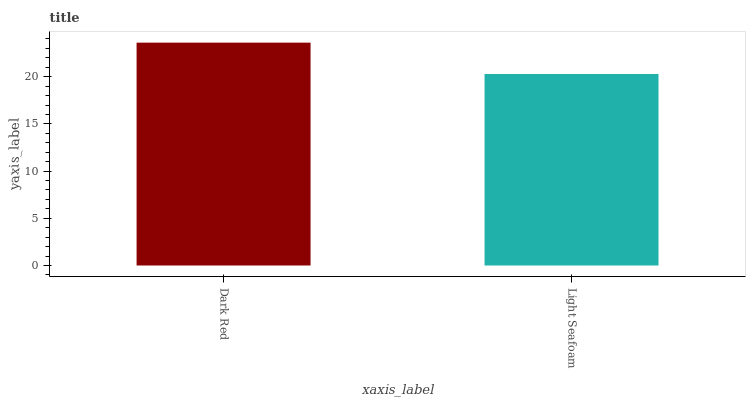Is Light Seafoam the maximum?
Answer yes or no. No. Is Dark Red greater than Light Seafoam?
Answer yes or no. Yes. Is Light Seafoam less than Dark Red?
Answer yes or no. Yes. Is Light Seafoam greater than Dark Red?
Answer yes or no. No. Is Dark Red less than Light Seafoam?
Answer yes or no. No. Is Dark Red the high median?
Answer yes or no. Yes. Is Light Seafoam the low median?
Answer yes or no. Yes. Is Light Seafoam the high median?
Answer yes or no. No. Is Dark Red the low median?
Answer yes or no. No. 